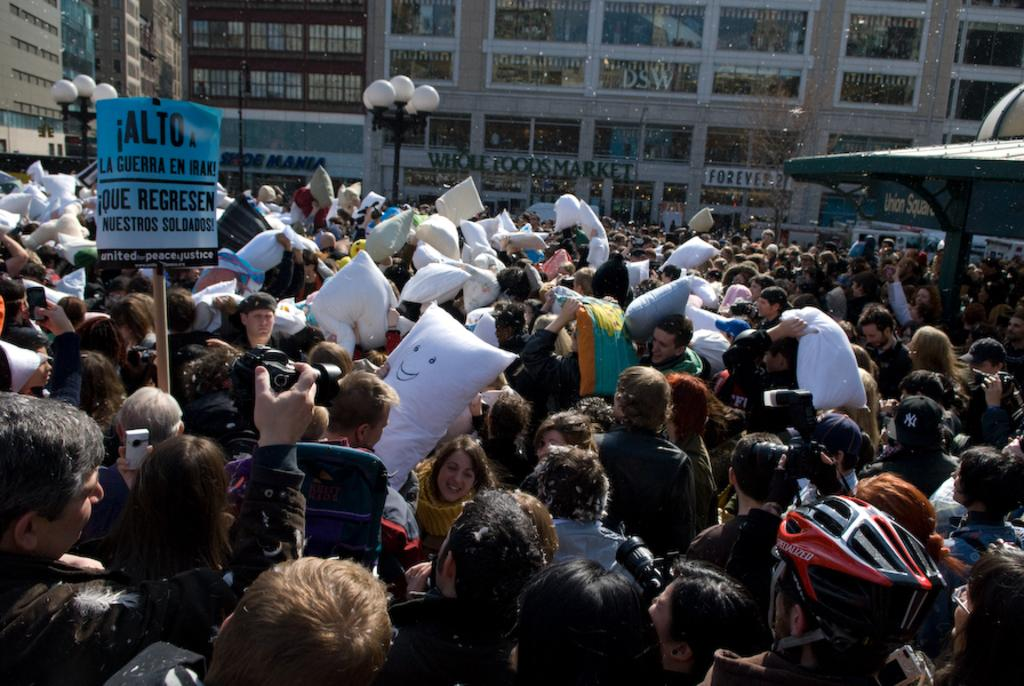What is happening in the image? There are people standing in the image. What are the people holding in their hands? The people are holding objects in their hands. What can be seen in the background of the image? There are street lights and buildings in the background of the image. Are there any cobwebs visible in the image? There is no mention of cobwebs in the provided facts, so we cannot determine if any are present in the image. 